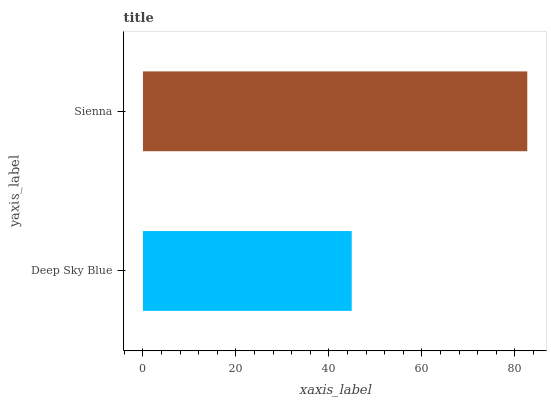Is Deep Sky Blue the minimum?
Answer yes or no. Yes. Is Sienna the maximum?
Answer yes or no. Yes. Is Sienna the minimum?
Answer yes or no. No. Is Sienna greater than Deep Sky Blue?
Answer yes or no. Yes. Is Deep Sky Blue less than Sienna?
Answer yes or no. Yes. Is Deep Sky Blue greater than Sienna?
Answer yes or no. No. Is Sienna less than Deep Sky Blue?
Answer yes or no. No. Is Sienna the high median?
Answer yes or no. Yes. Is Deep Sky Blue the low median?
Answer yes or no. Yes. Is Deep Sky Blue the high median?
Answer yes or no. No. Is Sienna the low median?
Answer yes or no. No. 